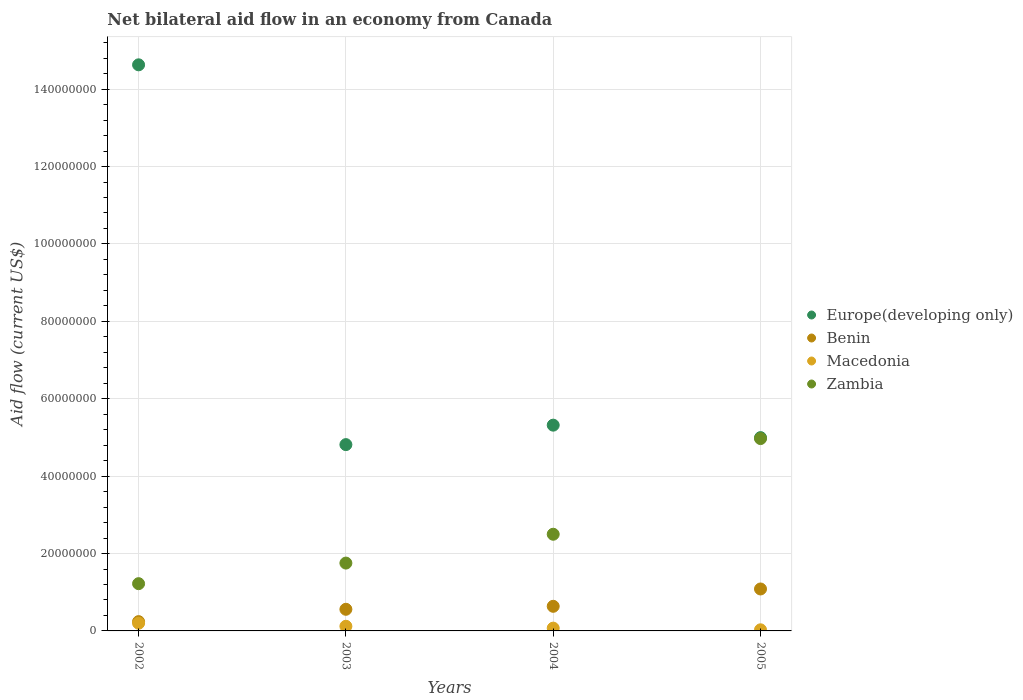What is the net bilateral aid flow in Macedonia in 2004?
Make the answer very short. 7.20e+05. Across all years, what is the maximum net bilateral aid flow in Europe(developing only)?
Make the answer very short. 1.46e+08. Across all years, what is the minimum net bilateral aid flow in Benin?
Your answer should be very brief. 2.40e+06. What is the total net bilateral aid flow in Zambia in the graph?
Provide a succinct answer. 1.04e+08. What is the difference between the net bilateral aid flow in Zambia in 2002 and that in 2004?
Offer a very short reply. -1.28e+07. What is the difference between the net bilateral aid flow in Zambia in 2004 and the net bilateral aid flow in Europe(developing only) in 2005?
Your response must be concise. -2.50e+07. What is the average net bilateral aid flow in Europe(developing only) per year?
Your answer should be compact. 7.44e+07. In the year 2002, what is the difference between the net bilateral aid flow in Benin and net bilateral aid flow in Macedonia?
Your answer should be very brief. 4.10e+05. What is the ratio of the net bilateral aid flow in Zambia in 2003 to that in 2005?
Your answer should be compact. 0.35. Is the difference between the net bilateral aid flow in Benin in 2002 and 2004 greater than the difference between the net bilateral aid flow in Macedonia in 2002 and 2004?
Keep it short and to the point. No. What is the difference between the highest and the second highest net bilateral aid flow in Zambia?
Your response must be concise. 2.47e+07. What is the difference between the highest and the lowest net bilateral aid flow in Europe(developing only)?
Provide a short and direct response. 9.81e+07. In how many years, is the net bilateral aid flow in Zambia greater than the average net bilateral aid flow in Zambia taken over all years?
Provide a succinct answer. 1. Is it the case that in every year, the sum of the net bilateral aid flow in Zambia and net bilateral aid flow in Macedonia  is greater than the sum of net bilateral aid flow in Benin and net bilateral aid flow in Europe(developing only)?
Ensure brevity in your answer.  Yes. Does the net bilateral aid flow in Benin monotonically increase over the years?
Give a very brief answer. Yes. Is the net bilateral aid flow in Benin strictly greater than the net bilateral aid flow in Europe(developing only) over the years?
Your answer should be very brief. No. Is the net bilateral aid flow in Zambia strictly less than the net bilateral aid flow in Benin over the years?
Keep it short and to the point. No. What is the difference between two consecutive major ticks on the Y-axis?
Your answer should be compact. 2.00e+07. Does the graph contain grids?
Offer a very short reply. Yes. How many legend labels are there?
Provide a short and direct response. 4. How are the legend labels stacked?
Your response must be concise. Vertical. What is the title of the graph?
Offer a terse response. Net bilateral aid flow in an economy from Canada. Does "Kuwait" appear as one of the legend labels in the graph?
Your answer should be compact. No. What is the label or title of the X-axis?
Make the answer very short. Years. What is the label or title of the Y-axis?
Your answer should be very brief. Aid flow (current US$). What is the Aid flow (current US$) of Europe(developing only) in 2002?
Provide a succinct answer. 1.46e+08. What is the Aid flow (current US$) of Benin in 2002?
Keep it short and to the point. 2.40e+06. What is the Aid flow (current US$) of Macedonia in 2002?
Your answer should be very brief. 1.99e+06. What is the Aid flow (current US$) of Zambia in 2002?
Your answer should be very brief. 1.22e+07. What is the Aid flow (current US$) of Europe(developing only) in 2003?
Give a very brief answer. 4.81e+07. What is the Aid flow (current US$) of Benin in 2003?
Offer a very short reply. 5.59e+06. What is the Aid flow (current US$) of Macedonia in 2003?
Make the answer very short. 1.20e+06. What is the Aid flow (current US$) of Zambia in 2003?
Make the answer very short. 1.75e+07. What is the Aid flow (current US$) in Europe(developing only) in 2004?
Your answer should be very brief. 5.32e+07. What is the Aid flow (current US$) in Benin in 2004?
Ensure brevity in your answer.  6.36e+06. What is the Aid flow (current US$) of Macedonia in 2004?
Offer a terse response. 7.20e+05. What is the Aid flow (current US$) in Zambia in 2004?
Offer a very short reply. 2.50e+07. What is the Aid flow (current US$) in Europe(developing only) in 2005?
Provide a short and direct response. 5.00e+07. What is the Aid flow (current US$) in Benin in 2005?
Offer a very short reply. 1.08e+07. What is the Aid flow (current US$) of Zambia in 2005?
Give a very brief answer. 4.97e+07. Across all years, what is the maximum Aid flow (current US$) of Europe(developing only)?
Your answer should be compact. 1.46e+08. Across all years, what is the maximum Aid flow (current US$) in Benin?
Offer a very short reply. 1.08e+07. Across all years, what is the maximum Aid flow (current US$) of Macedonia?
Offer a terse response. 1.99e+06. Across all years, what is the maximum Aid flow (current US$) of Zambia?
Ensure brevity in your answer.  4.97e+07. Across all years, what is the minimum Aid flow (current US$) in Europe(developing only)?
Ensure brevity in your answer.  4.81e+07. Across all years, what is the minimum Aid flow (current US$) of Benin?
Provide a short and direct response. 2.40e+06. Across all years, what is the minimum Aid flow (current US$) of Macedonia?
Give a very brief answer. 2.90e+05. Across all years, what is the minimum Aid flow (current US$) of Zambia?
Provide a succinct answer. 1.22e+07. What is the total Aid flow (current US$) in Europe(developing only) in the graph?
Make the answer very short. 2.98e+08. What is the total Aid flow (current US$) of Benin in the graph?
Ensure brevity in your answer.  2.52e+07. What is the total Aid flow (current US$) in Macedonia in the graph?
Give a very brief answer. 4.20e+06. What is the total Aid flow (current US$) in Zambia in the graph?
Give a very brief answer. 1.04e+08. What is the difference between the Aid flow (current US$) in Europe(developing only) in 2002 and that in 2003?
Make the answer very short. 9.81e+07. What is the difference between the Aid flow (current US$) in Benin in 2002 and that in 2003?
Your answer should be compact. -3.19e+06. What is the difference between the Aid flow (current US$) of Macedonia in 2002 and that in 2003?
Your answer should be compact. 7.90e+05. What is the difference between the Aid flow (current US$) in Zambia in 2002 and that in 2003?
Give a very brief answer. -5.32e+06. What is the difference between the Aid flow (current US$) in Europe(developing only) in 2002 and that in 2004?
Keep it short and to the point. 9.31e+07. What is the difference between the Aid flow (current US$) of Benin in 2002 and that in 2004?
Make the answer very short. -3.96e+06. What is the difference between the Aid flow (current US$) of Macedonia in 2002 and that in 2004?
Make the answer very short. 1.27e+06. What is the difference between the Aid flow (current US$) in Zambia in 2002 and that in 2004?
Keep it short and to the point. -1.28e+07. What is the difference between the Aid flow (current US$) in Europe(developing only) in 2002 and that in 2005?
Ensure brevity in your answer.  9.63e+07. What is the difference between the Aid flow (current US$) in Benin in 2002 and that in 2005?
Provide a short and direct response. -8.44e+06. What is the difference between the Aid flow (current US$) of Macedonia in 2002 and that in 2005?
Your response must be concise. 1.70e+06. What is the difference between the Aid flow (current US$) of Zambia in 2002 and that in 2005?
Offer a terse response. -3.75e+07. What is the difference between the Aid flow (current US$) of Europe(developing only) in 2003 and that in 2004?
Make the answer very short. -5.03e+06. What is the difference between the Aid flow (current US$) of Benin in 2003 and that in 2004?
Your answer should be very brief. -7.70e+05. What is the difference between the Aid flow (current US$) of Zambia in 2003 and that in 2004?
Your answer should be compact. -7.45e+06. What is the difference between the Aid flow (current US$) of Europe(developing only) in 2003 and that in 2005?
Make the answer very short. -1.81e+06. What is the difference between the Aid flow (current US$) of Benin in 2003 and that in 2005?
Provide a short and direct response. -5.25e+06. What is the difference between the Aid flow (current US$) in Macedonia in 2003 and that in 2005?
Offer a very short reply. 9.10e+05. What is the difference between the Aid flow (current US$) in Zambia in 2003 and that in 2005?
Provide a short and direct response. -3.22e+07. What is the difference between the Aid flow (current US$) of Europe(developing only) in 2004 and that in 2005?
Keep it short and to the point. 3.22e+06. What is the difference between the Aid flow (current US$) of Benin in 2004 and that in 2005?
Keep it short and to the point. -4.48e+06. What is the difference between the Aid flow (current US$) of Macedonia in 2004 and that in 2005?
Your answer should be compact. 4.30e+05. What is the difference between the Aid flow (current US$) of Zambia in 2004 and that in 2005?
Provide a short and direct response. -2.47e+07. What is the difference between the Aid flow (current US$) of Europe(developing only) in 2002 and the Aid flow (current US$) of Benin in 2003?
Your response must be concise. 1.41e+08. What is the difference between the Aid flow (current US$) of Europe(developing only) in 2002 and the Aid flow (current US$) of Macedonia in 2003?
Offer a terse response. 1.45e+08. What is the difference between the Aid flow (current US$) in Europe(developing only) in 2002 and the Aid flow (current US$) in Zambia in 2003?
Your response must be concise. 1.29e+08. What is the difference between the Aid flow (current US$) in Benin in 2002 and the Aid flow (current US$) in Macedonia in 2003?
Ensure brevity in your answer.  1.20e+06. What is the difference between the Aid flow (current US$) of Benin in 2002 and the Aid flow (current US$) of Zambia in 2003?
Make the answer very short. -1.51e+07. What is the difference between the Aid flow (current US$) in Macedonia in 2002 and the Aid flow (current US$) in Zambia in 2003?
Provide a short and direct response. -1.55e+07. What is the difference between the Aid flow (current US$) in Europe(developing only) in 2002 and the Aid flow (current US$) in Benin in 2004?
Keep it short and to the point. 1.40e+08. What is the difference between the Aid flow (current US$) in Europe(developing only) in 2002 and the Aid flow (current US$) in Macedonia in 2004?
Provide a succinct answer. 1.46e+08. What is the difference between the Aid flow (current US$) in Europe(developing only) in 2002 and the Aid flow (current US$) in Zambia in 2004?
Keep it short and to the point. 1.21e+08. What is the difference between the Aid flow (current US$) in Benin in 2002 and the Aid flow (current US$) in Macedonia in 2004?
Give a very brief answer. 1.68e+06. What is the difference between the Aid flow (current US$) in Benin in 2002 and the Aid flow (current US$) in Zambia in 2004?
Your answer should be compact. -2.26e+07. What is the difference between the Aid flow (current US$) in Macedonia in 2002 and the Aid flow (current US$) in Zambia in 2004?
Your answer should be very brief. -2.30e+07. What is the difference between the Aid flow (current US$) of Europe(developing only) in 2002 and the Aid flow (current US$) of Benin in 2005?
Offer a very short reply. 1.35e+08. What is the difference between the Aid flow (current US$) of Europe(developing only) in 2002 and the Aid flow (current US$) of Macedonia in 2005?
Give a very brief answer. 1.46e+08. What is the difference between the Aid flow (current US$) of Europe(developing only) in 2002 and the Aid flow (current US$) of Zambia in 2005?
Offer a very short reply. 9.66e+07. What is the difference between the Aid flow (current US$) in Benin in 2002 and the Aid flow (current US$) in Macedonia in 2005?
Your answer should be compact. 2.11e+06. What is the difference between the Aid flow (current US$) of Benin in 2002 and the Aid flow (current US$) of Zambia in 2005?
Offer a terse response. -4.73e+07. What is the difference between the Aid flow (current US$) of Macedonia in 2002 and the Aid flow (current US$) of Zambia in 2005?
Your answer should be compact. -4.77e+07. What is the difference between the Aid flow (current US$) of Europe(developing only) in 2003 and the Aid flow (current US$) of Benin in 2004?
Make the answer very short. 4.18e+07. What is the difference between the Aid flow (current US$) of Europe(developing only) in 2003 and the Aid flow (current US$) of Macedonia in 2004?
Your response must be concise. 4.74e+07. What is the difference between the Aid flow (current US$) of Europe(developing only) in 2003 and the Aid flow (current US$) of Zambia in 2004?
Keep it short and to the point. 2.32e+07. What is the difference between the Aid flow (current US$) of Benin in 2003 and the Aid flow (current US$) of Macedonia in 2004?
Provide a succinct answer. 4.87e+06. What is the difference between the Aid flow (current US$) of Benin in 2003 and the Aid flow (current US$) of Zambia in 2004?
Give a very brief answer. -1.94e+07. What is the difference between the Aid flow (current US$) in Macedonia in 2003 and the Aid flow (current US$) in Zambia in 2004?
Your answer should be compact. -2.38e+07. What is the difference between the Aid flow (current US$) in Europe(developing only) in 2003 and the Aid flow (current US$) in Benin in 2005?
Give a very brief answer. 3.73e+07. What is the difference between the Aid flow (current US$) in Europe(developing only) in 2003 and the Aid flow (current US$) in Macedonia in 2005?
Provide a short and direct response. 4.78e+07. What is the difference between the Aid flow (current US$) of Europe(developing only) in 2003 and the Aid flow (current US$) of Zambia in 2005?
Offer a terse response. -1.56e+06. What is the difference between the Aid flow (current US$) of Benin in 2003 and the Aid flow (current US$) of Macedonia in 2005?
Offer a terse response. 5.30e+06. What is the difference between the Aid flow (current US$) in Benin in 2003 and the Aid flow (current US$) in Zambia in 2005?
Give a very brief answer. -4.41e+07. What is the difference between the Aid flow (current US$) of Macedonia in 2003 and the Aid flow (current US$) of Zambia in 2005?
Offer a terse response. -4.85e+07. What is the difference between the Aid flow (current US$) in Europe(developing only) in 2004 and the Aid flow (current US$) in Benin in 2005?
Give a very brief answer. 4.23e+07. What is the difference between the Aid flow (current US$) in Europe(developing only) in 2004 and the Aid flow (current US$) in Macedonia in 2005?
Make the answer very short. 5.29e+07. What is the difference between the Aid flow (current US$) in Europe(developing only) in 2004 and the Aid flow (current US$) in Zambia in 2005?
Provide a short and direct response. 3.47e+06. What is the difference between the Aid flow (current US$) of Benin in 2004 and the Aid flow (current US$) of Macedonia in 2005?
Your answer should be very brief. 6.07e+06. What is the difference between the Aid flow (current US$) of Benin in 2004 and the Aid flow (current US$) of Zambia in 2005?
Your response must be concise. -4.33e+07. What is the difference between the Aid flow (current US$) of Macedonia in 2004 and the Aid flow (current US$) of Zambia in 2005?
Your answer should be compact. -4.90e+07. What is the average Aid flow (current US$) in Europe(developing only) per year?
Give a very brief answer. 7.44e+07. What is the average Aid flow (current US$) of Benin per year?
Your response must be concise. 6.30e+06. What is the average Aid flow (current US$) in Macedonia per year?
Your answer should be very brief. 1.05e+06. What is the average Aid flow (current US$) in Zambia per year?
Make the answer very short. 2.61e+07. In the year 2002, what is the difference between the Aid flow (current US$) of Europe(developing only) and Aid flow (current US$) of Benin?
Offer a very short reply. 1.44e+08. In the year 2002, what is the difference between the Aid flow (current US$) in Europe(developing only) and Aid flow (current US$) in Macedonia?
Provide a short and direct response. 1.44e+08. In the year 2002, what is the difference between the Aid flow (current US$) of Europe(developing only) and Aid flow (current US$) of Zambia?
Make the answer very short. 1.34e+08. In the year 2002, what is the difference between the Aid flow (current US$) of Benin and Aid flow (current US$) of Zambia?
Provide a short and direct response. -9.81e+06. In the year 2002, what is the difference between the Aid flow (current US$) in Macedonia and Aid flow (current US$) in Zambia?
Ensure brevity in your answer.  -1.02e+07. In the year 2003, what is the difference between the Aid flow (current US$) of Europe(developing only) and Aid flow (current US$) of Benin?
Give a very brief answer. 4.26e+07. In the year 2003, what is the difference between the Aid flow (current US$) in Europe(developing only) and Aid flow (current US$) in Macedonia?
Offer a very short reply. 4.69e+07. In the year 2003, what is the difference between the Aid flow (current US$) in Europe(developing only) and Aid flow (current US$) in Zambia?
Your answer should be compact. 3.06e+07. In the year 2003, what is the difference between the Aid flow (current US$) in Benin and Aid flow (current US$) in Macedonia?
Offer a terse response. 4.39e+06. In the year 2003, what is the difference between the Aid flow (current US$) in Benin and Aid flow (current US$) in Zambia?
Offer a very short reply. -1.19e+07. In the year 2003, what is the difference between the Aid flow (current US$) of Macedonia and Aid flow (current US$) of Zambia?
Ensure brevity in your answer.  -1.63e+07. In the year 2004, what is the difference between the Aid flow (current US$) of Europe(developing only) and Aid flow (current US$) of Benin?
Your answer should be compact. 4.68e+07. In the year 2004, what is the difference between the Aid flow (current US$) in Europe(developing only) and Aid flow (current US$) in Macedonia?
Give a very brief answer. 5.24e+07. In the year 2004, what is the difference between the Aid flow (current US$) in Europe(developing only) and Aid flow (current US$) in Zambia?
Make the answer very short. 2.82e+07. In the year 2004, what is the difference between the Aid flow (current US$) of Benin and Aid flow (current US$) of Macedonia?
Offer a terse response. 5.64e+06. In the year 2004, what is the difference between the Aid flow (current US$) of Benin and Aid flow (current US$) of Zambia?
Give a very brief answer. -1.86e+07. In the year 2004, what is the difference between the Aid flow (current US$) in Macedonia and Aid flow (current US$) in Zambia?
Provide a short and direct response. -2.43e+07. In the year 2005, what is the difference between the Aid flow (current US$) of Europe(developing only) and Aid flow (current US$) of Benin?
Offer a terse response. 3.91e+07. In the year 2005, what is the difference between the Aid flow (current US$) in Europe(developing only) and Aid flow (current US$) in Macedonia?
Your answer should be very brief. 4.97e+07. In the year 2005, what is the difference between the Aid flow (current US$) in Benin and Aid flow (current US$) in Macedonia?
Ensure brevity in your answer.  1.06e+07. In the year 2005, what is the difference between the Aid flow (current US$) of Benin and Aid flow (current US$) of Zambia?
Your answer should be compact. -3.89e+07. In the year 2005, what is the difference between the Aid flow (current US$) of Macedonia and Aid flow (current US$) of Zambia?
Your response must be concise. -4.94e+07. What is the ratio of the Aid flow (current US$) of Europe(developing only) in 2002 to that in 2003?
Make the answer very short. 3.04. What is the ratio of the Aid flow (current US$) of Benin in 2002 to that in 2003?
Give a very brief answer. 0.43. What is the ratio of the Aid flow (current US$) of Macedonia in 2002 to that in 2003?
Provide a succinct answer. 1.66. What is the ratio of the Aid flow (current US$) in Zambia in 2002 to that in 2003?
Provide a succinct answer. 0.7. What is the ratio of the Aid flow (current US$) of Europe(developing only) in 2002 to that in 2004?
Provide a short and direct response. 2.75. What is the ratio of the Aid flow (current US$) of Benin in 2002 to that in 2004?
Provide a short and direct response. 0.38. What is the ratio of the Aid flow (current US$) of Macedonia in 2002 to that in 2004?
Provide a short and direct response. 2.76. What is the ratio of the Aid flow (current US$) of Zambia in 2002 to that in 2004?
Offer a terse response. 0.49. What is the ratio of the Aid flow (current US$) of Europe(developing only) in 2002 to that in 2005?
Make the answer very short. 2.93. What is the ratio of the Aid flow (current US$) in Benin in 2002 to that in 2005?
Provide a succinct answer. 0.22. What is the ratio of the Aid flow (current US$) of Macedonia in 2002 to that in 2005?
Your response must be concise. 6.86. What is the ratio of the Aid flow (current US$) in Zambia in 2002 to that in 2005?
Offer a very short reply. 0.25. What is the ratio of the Aid flow (current US$) of Europe(developing only) in 2003 to that in 2004?
Keep it short and to the point. 0.91. What is the ratio of the Aid flow (current US$) of Benin in 2003 to that in 2004?
Ensure brevity in your answer.  0.88. What is the ratio of the Aid flow (current US$) of Macedonia in 2003 to that in 2004?
Give a very brief answer. 1.67. What is the ratio of the Aid flow (current US$) in Zambia in 2003 to that in 2004?
Make the answer very short. 0.7. What is the ratio of the Aid flow (current US$) in Europe(developing only) in 2003 to that in 2005?
Give a very brief answer. 0.96. What is the ratio of the Aid flow (current US$) in Benin in 2003 to that in 2005?
Make the answer very short. 0.52. What is the ratio of the Aid flow (current US$) of Macedonia in 2003 to that in 2005?
Your answer should be very brief. 4.14. What is the ratio of the Aid flow (current US$) of Zambia in 2003 to that in 2005?
Make the answer very short. 0.35. What is the ratio of the Aid flow (current US$) in Europe(developing only) in 2004 to that in 2005?
Your answer should be compact. 1.06. What is the ratio of the Aid flow (current US$) of Benin in 2004 to that in 2005?
Offer a terse response. 0.59. What is the ratio of the Aid flow (current US$) of Macedonia in 2004 to that in 2005?
Ensure brevity in your answer.  2.48. What is the ratio of the Aid flow (current US$) in Zambia in 2004 to that in 2005?
Offer a terse response. 0.5. What is the difference between the highest and the second highest Aid flow (current US$) in Europe(developing only)?
Give a very brief answer. 9.31e+07. What is the difference between the highest and the second highest Aid flow (current US$) of Benin?
Provide a succinct answer. 4.48e+06. What is the difference between the highest and the second highest Aid flow (current US$) in Macedonia?
Provide a short and direct response. 7.90e+05. What is the difference between the highest and the second highest Aid flow (current US$) in Zambia?
Your answer should be compact. 2.47e+07. What is the difference between the highest and the lowest Aid flow (current US$) in Europe(developing only)?
Your answer should be compact. 9.81e+07. What is the difference between the highest and the lowest Aid flow (current US$) in Benin?
Your answer should be compact. 8.44e+06. What is the difference between the highest and the lowest Aid flow (current US$) in Macedonia?
Offer a terse response. 1.70e+06. What is the difference between the highest and the lowest Aid flow (current US$) of Zambia?
Your answer should be compact. 3.75e+07. 